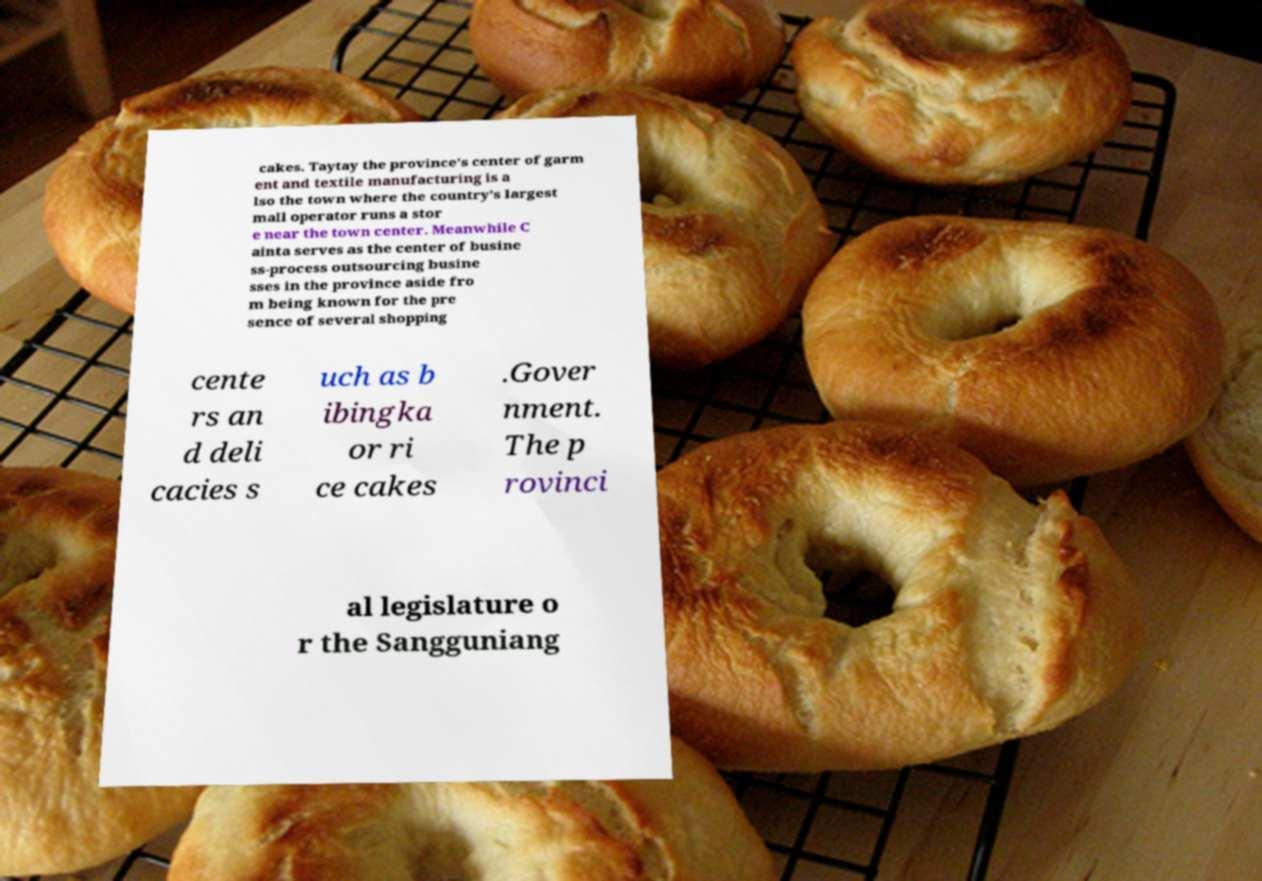Could you assist in decoding the text presented in this image and type it out clearly? cakes. Taytay the province's center of garm ent and textile manufacturing is a lso the town where the country's largest mall operator runs a stor e near the town center. Meanwhile C ainta serves as the center of busine ss-process outsourcing busine sses in the province aside fro m being known for the pre sence of several shopping cente rs an d deli cacies s uch as b ibingka or ri ce cakes .Gover nment. The p rovinci al legislature o r the Sangguniang 